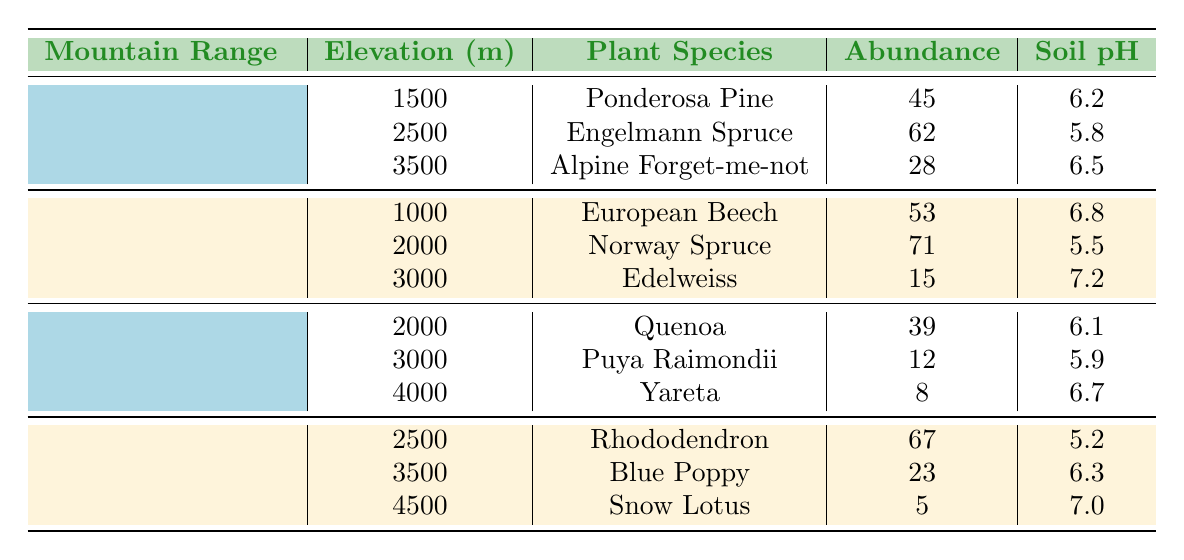What is the plant species with the highest abundance in the Rocky Mountains? In the Rocky Mountains, the species with the highest abundance is Engelmann Spruce, which has an abundance of 62.
Answer: Engelmann Spruce What is the average soil pH for plant species in the Andes? The species in the Andes have soil pH values of 6.1, 5.9, and 6.7. To find the average, sum these values (6.1 + 5.9 + 6.7 = 18.7) and divide by the number of species (3). Thus, the average soil pH is 18.7 / 3 = 6.23.
Answer: 6.23 How many plant species have an abundance greater than 20 in the Alps? In the Alps, the species with abundances are: European Beech (53), Norway Spruce (71), and Edelweiss (15). Out of these, two species (European Beech and Norway Spruce) have abundances greater than 20.
Answer: 2 Is the annual precipitation higher in the Himalayas compared to the Rocky Mountains? The annual precipitation in the Himalayas is 2000, 1500, and 300, while in the Rocky Mountains, it is 500, 750, and 900. The highest value in the Himalayas (2000) is greater than any values in the Rocky Mountains, confirming that the annual precipitation is higher in the Himalayas.
Answer: Yes What is the difference in abundance between the most and least abundant plant species across all mountain ranges? To find this, identify the most abundant species, Engelmann Spruce (62), and the least abundant species, Snow Lotus (5). The difference is calculated as 62 - 5 = 57.
Answer: 57 